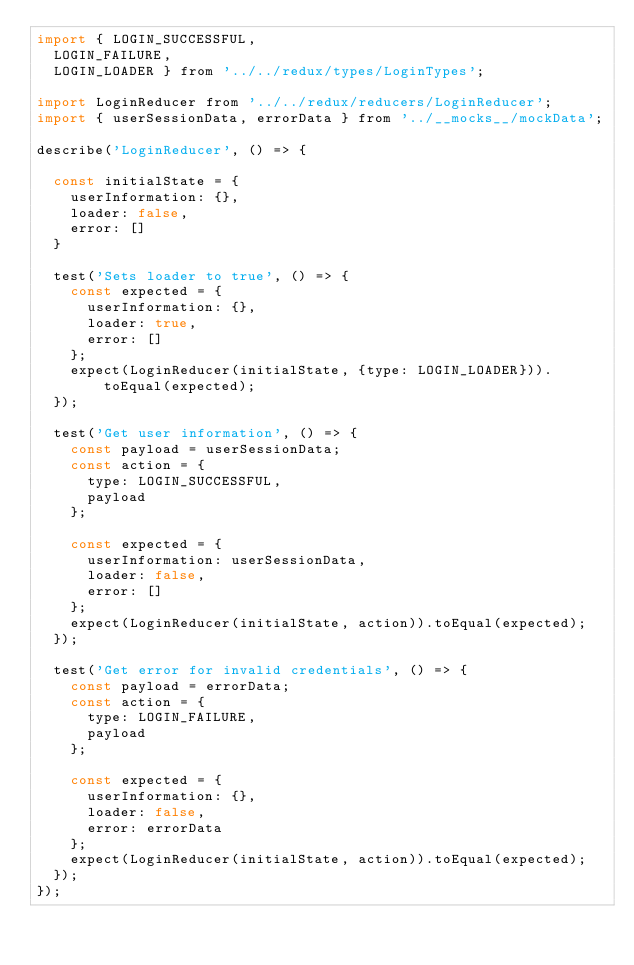Convert code to text. <code><loc_0><loc_0><loc_500><loc_500><_JavaScript_>import { LOGIN_SUCCESSFUL,
  LOGIN_FAILURE,
  LOGIN_LOADER } from '../../redux/types/LoginTypes';

import LoginReducer from '../../redux/reducers/LoginReducer';  
import { userSessionData, errorData } from '../__mocks__/mockData';

describe('LoginReducer', () => {

  const initialState = {
    userInformation: {},
    loader: false,
    error: []
  }

  test('Sets loader to true', () => {
    const expected = {
      userInformation: {},
      loader: true,
      error: []
    };
    expect(LoginReducer(initialState, {type: LOGIN_LOADER})).toEqual(expected);
  });

  test('Get user information', () => {
    const payload = userSessionData;
    const action = {
      type: LOGIN_SUCCESSFUL,
      payload
    };

    const expected = {
      userInformation: userSessionData,
      loader: false,
      error: []
    };
    expect(LoginReducer(initialState, action)).toEqual(expected);
  });

  test('Get error for invalid credentials', () => {
    const payload = errorData;
    const action = {
      type: LOGIN_FAILURE,
      payload
    };

    const expected = {
      userInformation: {},
      loader: false,
      error: errorData
    };
    expect(LoginReducer(initialState, action)).toEqual(expected);
  });
});</code> 